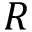<formula> <loc_0><loc_0><loc_500><loc_500>R</formula> 